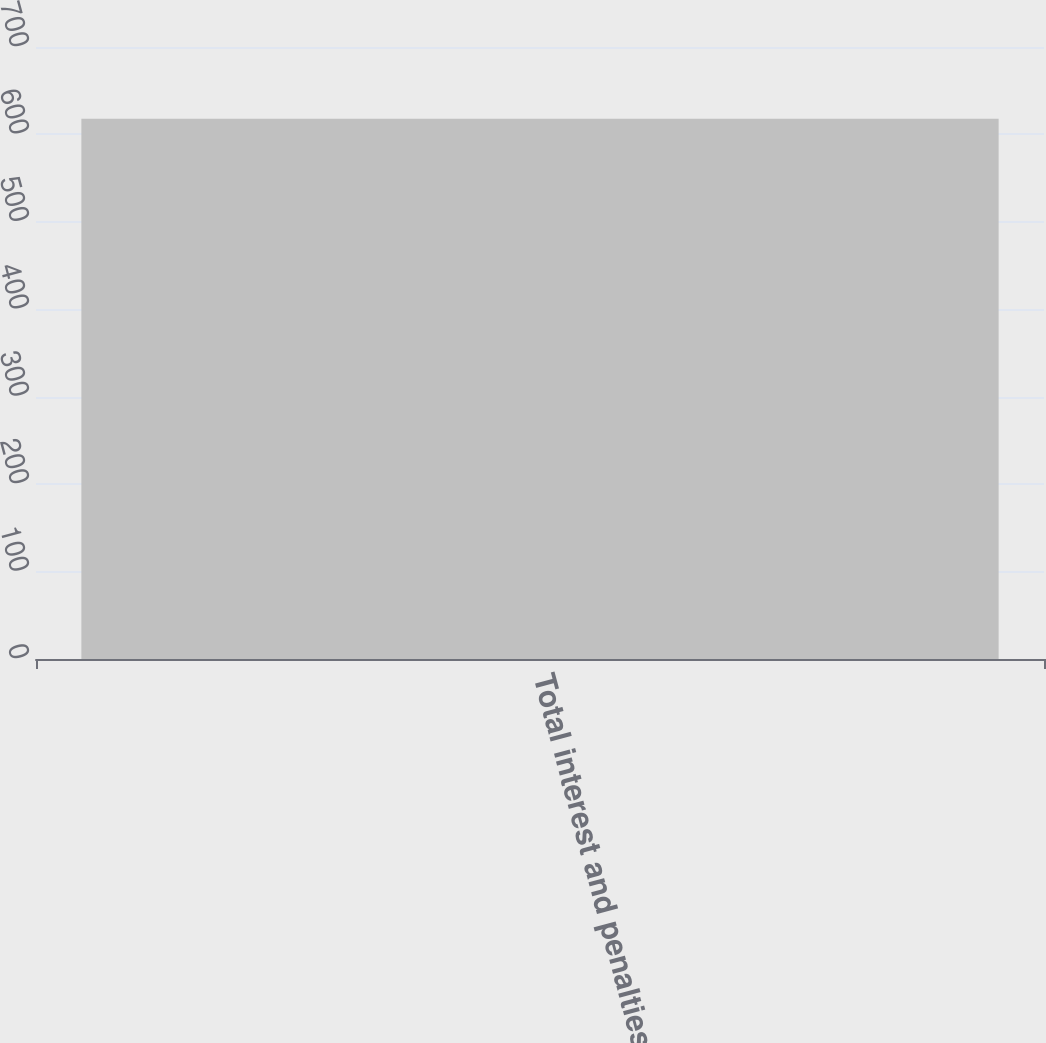Convert chart. <chart><loc_0><loc_0><loc_500><loc_500><bar_chart><fcel>Total interest and penalties<nl><fcel>618<nl></chart> 